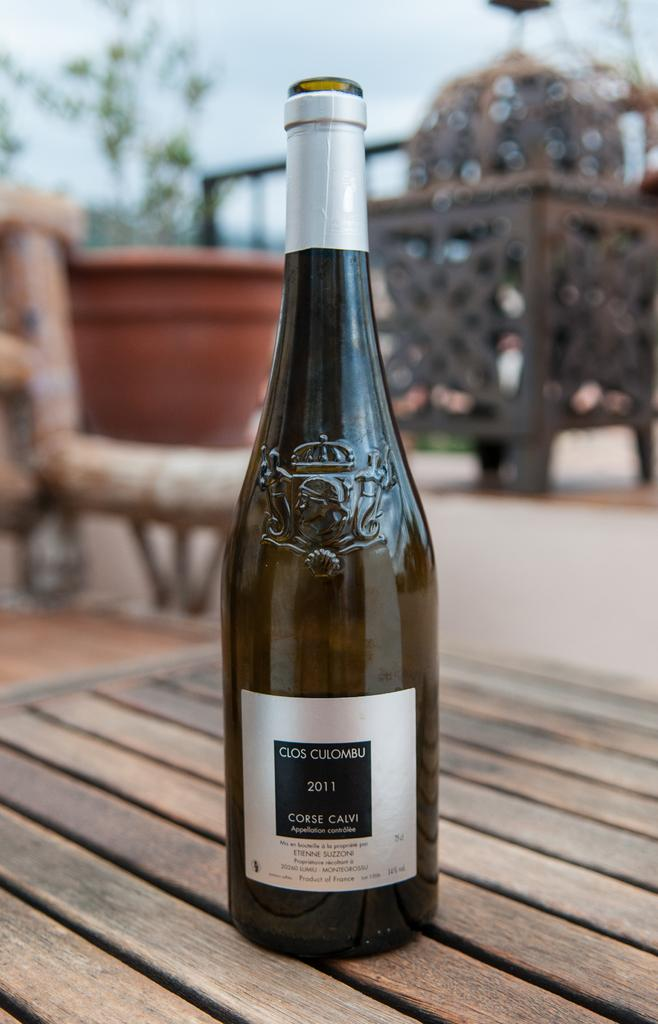What object is placed on the table in the image? There is a bottle on a table in the image. What can be seen at the back side in the image? There is a flower pot at the back side in the image. What type of punishment is being administered in the image? There is no punishment being administered in the image; it only features a bottle on a table and a flower pot at the back side. Whose birthday is being celebrated in the image? There is no indication of a birthday celebration in the image. 